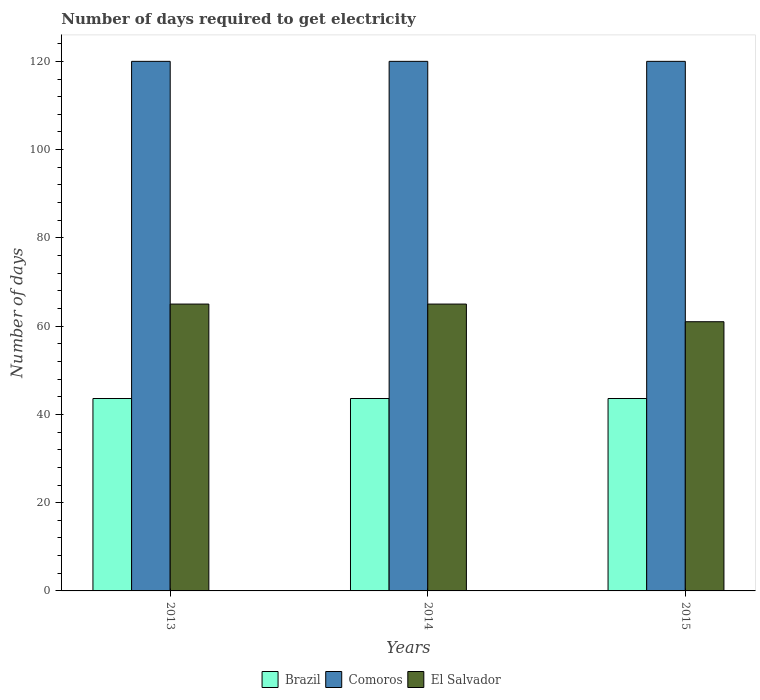How many groups of bars are there?
Provide a short and direct response. 3. How many bars are there on the 3rd tick from the right?
Ensure brevity in your answer.  3. What is the label of the 2nd group of bars from the left?
Ensure brevity in your answer.  2014. In how many cases, is the number of bars for a given year not equal to the number of legend labels?
Offer a very short reply. 0. What is the number of days required to get electricity in in Brazil in 2013?
Keep it short and to the point. 43.6. Across all years, what is the maximum number of days required to get electricity in in El Salvador?
Make the answer very short. 65. Across all years, what is the minimum number of days required to get electricity in in Comoros?
Your answer should be compact. 120. In which year was the number of days required to get electricity in in Comoros maximum?
Keep it short and to the point. 2013. What is the total number of days required to get electricity in in Comoros in the graph?
Offer a terse response. 360. What is the difference between the number of days required to get electricity in in Brazil in 2015 and the number of days required to get electricity in in El Salvador in 2013?
Give a very brief answer. -21.4. What is the average number of days required to get electricity in in El Salvador per year?
Your answer should be compact. 63.67. In the year 2015, what is the difference between the number of days required to get electricity in in Brazil and number of days required to get electricity in in Comoros?
Give a very brief answer. -76.4. Is the difference between the number of days required to get electricity in in Brazil in 2013 and 2014 greater than the difference between the number of days required to get electricity in in Comoros in 2013 and 2014?
Your answer should be compact. No. What is the difference between the highest and the lowest number of days required to get electricity in in El Salvador?
Your answer should be very brief. 4. In how many years, is the number of days required to get electricity in in Brazil greater than the average number of days required to get electricity in in Brazil taken over all years?
Provide a succinct answer. 0. Is the sum of the number of days required to get electricity in in El Salvador in 2013 and 2014 greater than the maximum number of days required to get electricity in in Comoros across all years?
Your response must be concise. Yes. What does the 2nd bar from the left in 2015 represents?
Provide a succinct answer. Comoros. Are all the bars in the graph horizontal?
Offer a very short reply. No. How many years are there in the graph?
Give a very brief answer. 3. What is the difference between two consecutive major ticks on the Y-axis?
Keep it short and to the point. 20. Are the values on the major ticks of Y-axis written in scientific E-notation?
Ensure brevity in your answer.  No. Does the graph contain any zero values?
Provide a succinct answer. No. What is the title of the graph?
Make the answer very short. Number of days required to get electricity. Does "Austria" appear as one of the legend labels in the graph?
Keep it short and to the point. No. What is the label or title of the X-axis?
Provide a short and direct response. Years. What is the label or title of the Y-axis?
Keep it short and to the point. Number of days. What is the Number of days of Brazil in 2013?
Your answer should be very brief. 43.6. What is the Number of days in Comoros in 2013?
Provide a short and direct response. 120. What is the Number of days of El Salvador in 2013?
Give a very brief answer. 65. What is the Number of days in Brazil in 2014?
Make the answer very short. 43.6. What is the Number of days of Comoros in 2014?
Offer a very short reply. 120. What is the Number of days of Brazil in 2015?
Provide a succinct answer. 43.6. What is the Number of days in Comoros in 2015?
Make the answer very short. 120. What is the Number of days of El Salvador in 2015?
Offer a very short reply. 61. Across all years, what is the maximum Number of days of Brazil?
Offer a terse response. 43.6. Across all years, what is the maximum Number of days of Comoros?
Ensure brevity in your answer.  120. Across all years, what is the maximum Number of days of El Salvador?
Ensure brevity in your answer.  65. Across all years, what is the minimum Number of days of Brazil?
Your answer should be very brief. 43.6. Across all years, what is the minimum Number of days in Comoros?
Your answer should be very brief. 120. What is the total Number of days in Brazil in the graph?
Offer a terse response. 130.8. What is the total Number of days of Comoros in the graph?
Provide a succinct answer. 360. What is the total Number of days of El Salvador in the graph?
Make the answer very short. 191. What is the difference between the Number of days of Brazil in 2013 and that in 2014?
Provide a succinct answer. 0. What is the difference between the Number of days of Comoros in 2013 and that in 2014?
Offer a very short reply. 0. What is the difference between the Number of days of Comoros in 2013 and that in 2015?
Keep it short and to the point. 0. What is the difference between the Number of days in El Salvador in 2014 and that in 2015?
Your answer should be very brief. 4. What is the difference between the Number of days of Brazil in 2013 and the Number of days of Comoros in 2014?
Offer a very short reply. -76.4. What is the difference between the Number of days in Brazil in 2013 and the Number of days in El Salvador in 2014?
Ensure brevity in your answer.  -21.4. What is the difference between the Number of days of Comoros in 2013 and the Number of days of El Salvador in 2014?
Provide a short and direct response. 55. What is the difference between the Number of days in Brazil in 2013 and the Number of days in Comoros in 2015?
Your answer should be compact. -76.4. What is the difference between the Number of days of Brazil in 2013 and the Number of days of El Salvador in 2015?
Provide a short and direct response. -17.4. What is the difference between the Number of days in Comoros in 2013 and the Number of days in El Salvador in 2015?
Keep it short and to the point. 59. What is the difference between the Number of days in Brazil in 2014 and the Number of days in Comoros in 2015?
Keep it short and to the point. -76.4. What is the difference between the Number of days of Brazil in 2014 and the Number of days of El Salvador in 2015?
Give a very brief answer. -17.4. What is the average Number of days in Brazil per year?
Your answer should be compact. 43.6. What is the average Number of days of Comoros per year?
Keep it short and to the point. 120. What is the average Number of days of El Salvador per year?
Your response must be concise. 63.67. In the year 2013, what is the difference between the Number of days in Brazil and Number of days in Comoros?
Offer a very short reply. -76.4. In the year 2013, what is the difference between the Number of days of Brazil and Number of days of El Salvador?
Your response must be concise. -21.4. In the year 2013, what is the difference between the Number of days in Comoros and Number of days in El Salvador?
Keep it short and to the point. 55. In the year 2014, what is the difference between the Number of days in Brazil and Number of days in Comoros?
Provide a succinct answer. -76.4. In the year 2014, what is the difference between the Number of days in Brazil and Number of days in El Salvador?
Your answer should be very brief. -21.4. In the year 2015, what is the difference between the Number of days in Brazil and Number of days in Comoros?
Your answer should be compact. -76.4. In the year 2015, what is the difference between the Number of days in Brazil and Number of days in El Salvador?
Give a very brief answer. -17.4. What is the ratio of the Number of days in Comoros in 2013 to that in 2014?
Provide a succinct answer. 1. What is the ratio of the Number of days of El Salvador in 2013 to that in 2015?
Make the answer very short. 1.07. What is the ratio of the Number of days of Comoros in 2014 to that in 2015?
Ensure brevity in your answer.  1. What is the ratio of the Number of days in El Salvador in 2014 to that in 2015?
Ensure brevity in your answer.  1.07. What is the difference between the highest and the second highest Number of days in Brazil?
Keep it short and to the point. 0. What is the difference between the highest and the second highest Number of days in Comoros?
Your response must be concise. 0. What is the difference between the highest and the lowest Number of days of Brazil?
Your response must be concise. 0. What is the difference between the highest and the lowest Number of days of El Salvador?
Give a very brief answer. 4. 